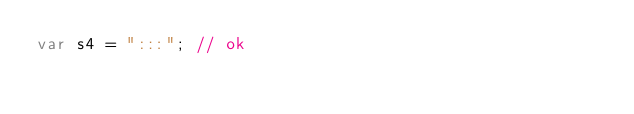<code> <loc_0><loc_0><loc_500><loc_500><_JavaScript_>var s4 = ":::"; // ok
</code> 